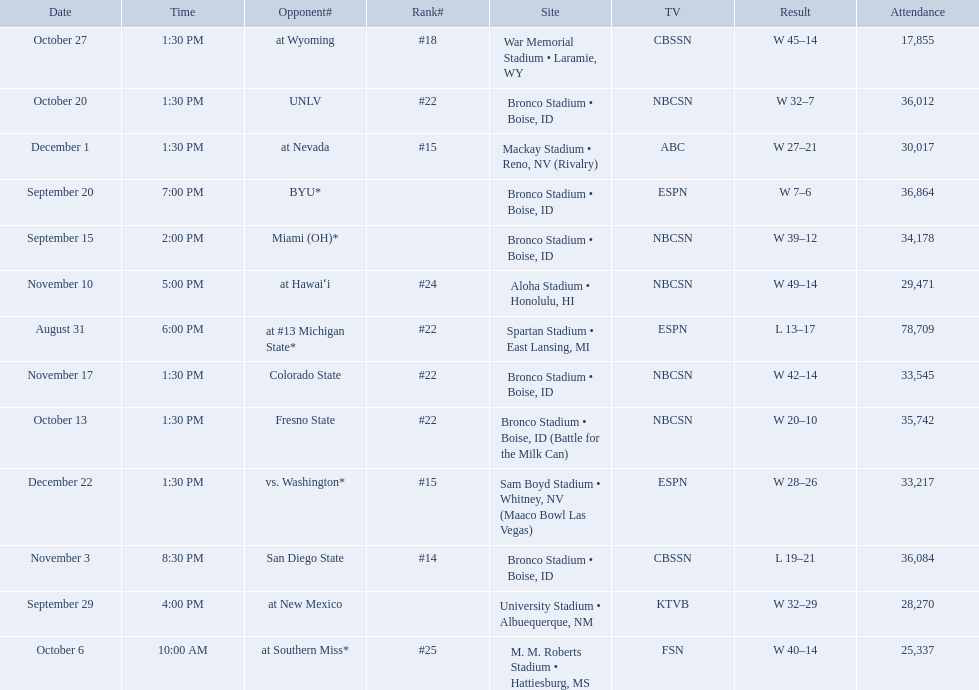What are all of the rankings? #22, , , , #25, #22, #22, #18, #14, #24, #22, #15, #15. Which of them was the best position? #14. 